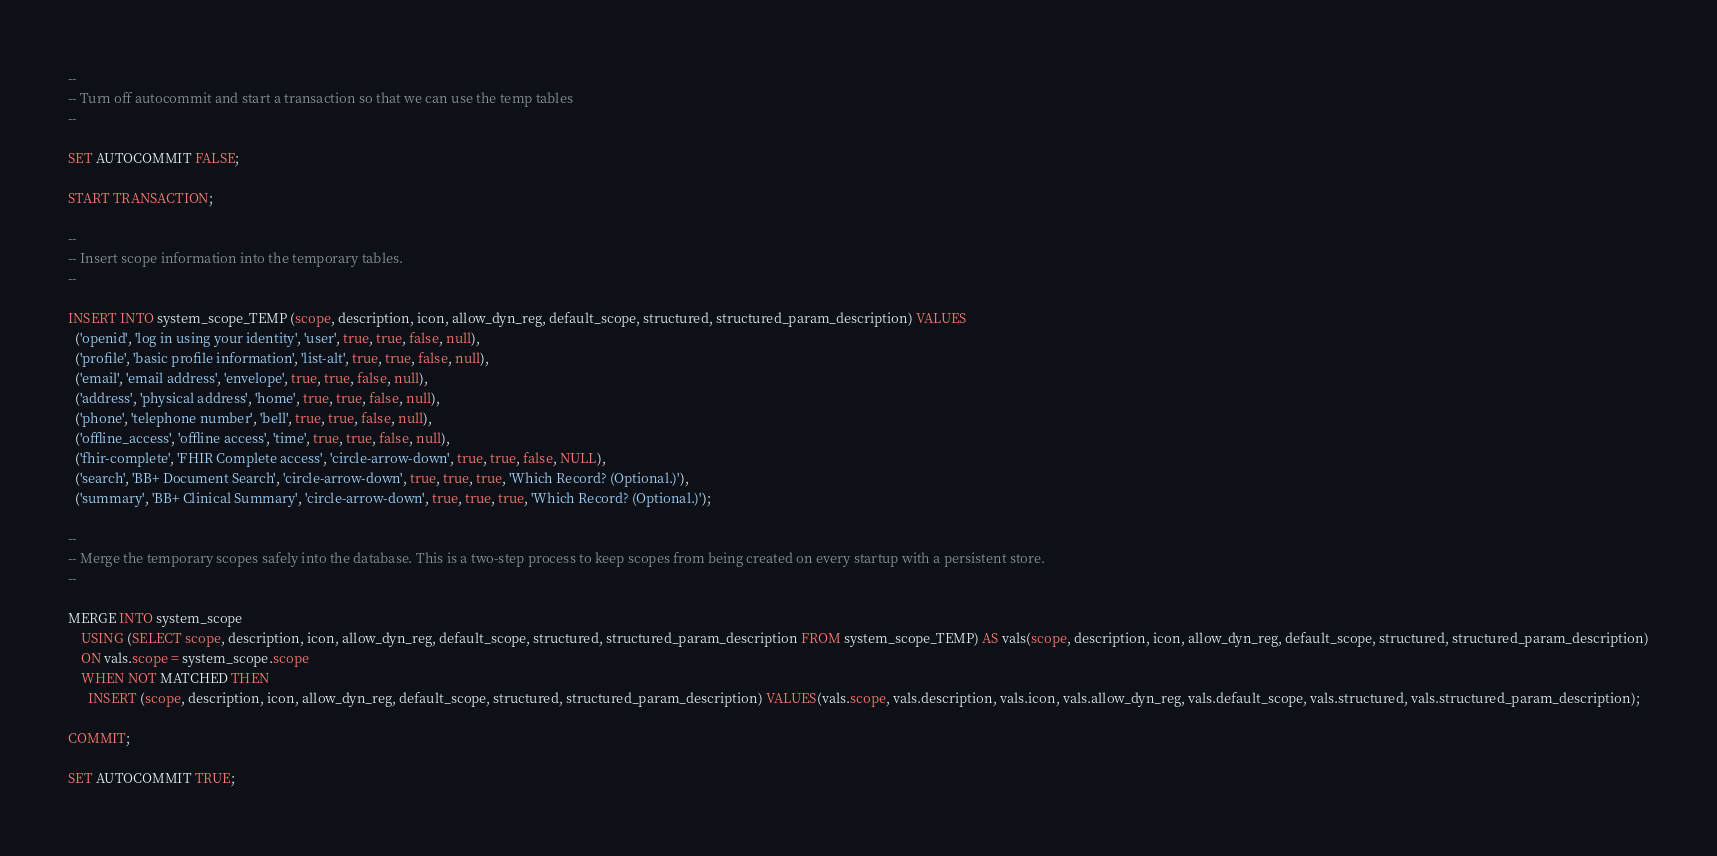Convert code to text. <code><loc_0><loc_0><loc_500><loc_500><_SQL_>--
-- Turn off autocommit and start a transaction so that we can use the temp tables
--

SET AUTOCOMMIT FALSE;

START TRANSACTION;

--
-- Insert scope information into the temporary tables.
-- 

INSERT INTO system_scope_TEMP (scope, description, icon, allow_dyn_reg, default_scope, structured, structured_param_description) VALUES
  ('openid', 'log in using your identity', 'user', true, true, false, null),
  ('profile', 'basic profile information', 'list-alt', true, true, false, null),
  ('email', 'email address', 'envelope', true, true, false, null),
  ('address', 'physical address', 'home', true, true, false, null),
  ('phone', 'telephone number', 'bell', true, true, false, null),
  ('offline_access', 'offline access', 'time', true, true, false, null),
  ('fhir-complete', 'FHIR Complete access', 'circle-arrow-down', true, true, false, NULL),
  ('search', 'BB+ Document Search', 'circle-arrow-down', true, true, true, 'Which Record? (Optional.)'),
  ('summary', 'BB+ Clinical Summary', 'circle-arrow-down', true, true, true, 'Which Record? (Optional.)');
   
--
-- Merge the temporary scopes safely into the database. This is a two-step process to keep scopes from being created on every startup with a persistent store.
--

MERGE INTO system_scope
	USING (SELECT scope, description, icon, allow_dyn_reg, default_scope, structured, structured_param_description FROM system_scope_TEMP) AS vals(scope, description, icon, allow_dyn_reg, default_scope, structured, structured_param_description)
	ON vals.scope = system_scope.scope
	WHEN NOT MATCHED THEN
	  INSERT (scope, description, icon, allow_dyn_reg, default_scope, structured, structured_param_description) VALUES(vals.scope, vals.description, vals.icon, vals.allow_dyn_reg, vals.default_scope, vals.structured, vals.structured_param_description);

COMMIT;

SET AUTOCOMMIT TRUE;
</code> 